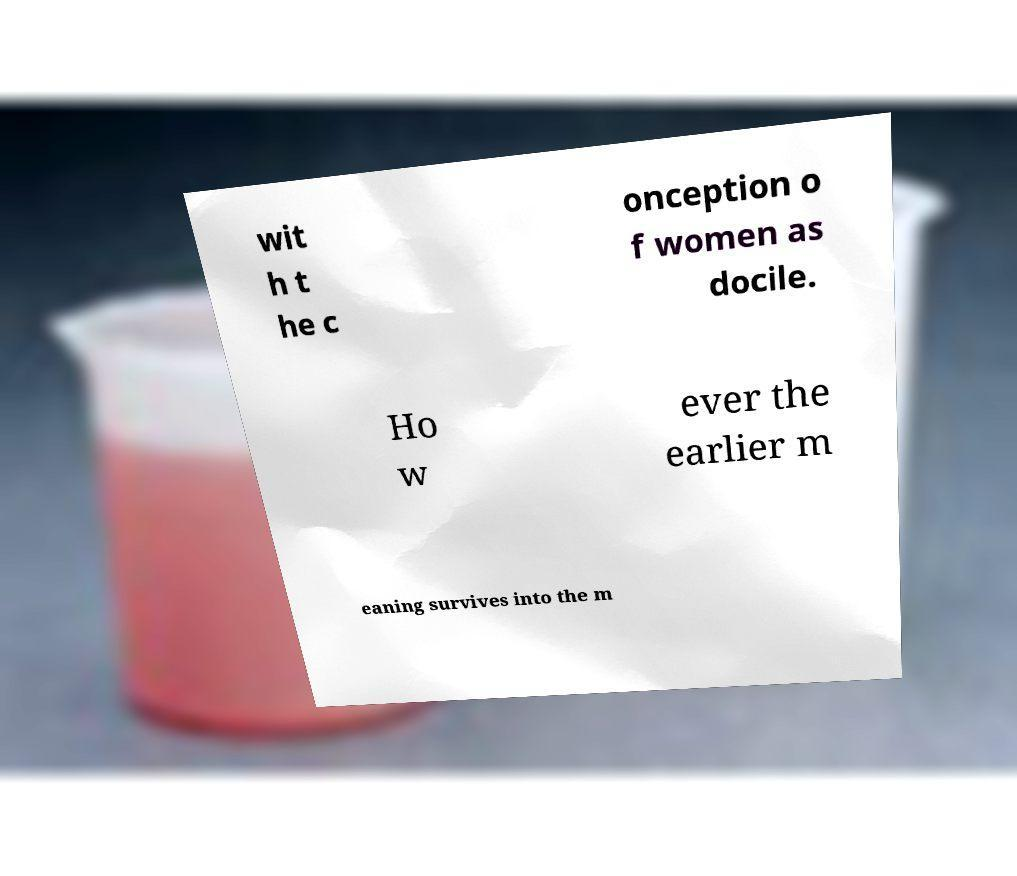For documentation purposes, I need the text within this image transcribed. Could you provide that? wit h t he c onception o f women as docile. Ho w ever the earlier m eaning survives into the m 